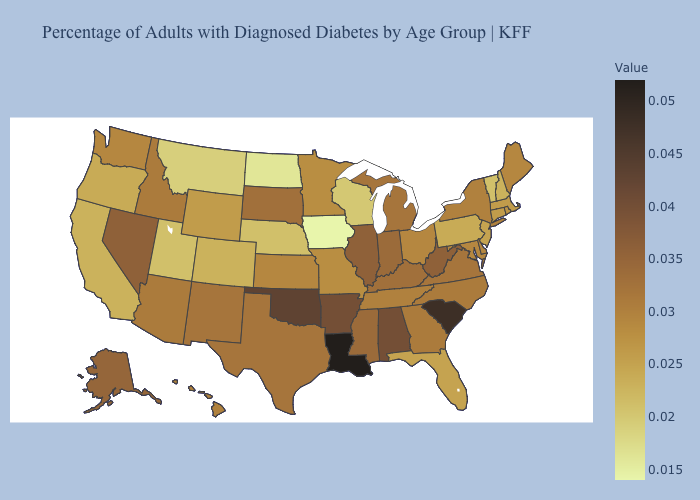Which states hav the highest value in the Northeast?
Be succinct. New York. Among the states that border North Dakota , which have the lowest value?
Short answer required. Montana. Does the map have missing data?
Short answer required. No. Which states have the lowest value in the Northeast?
Keep it brief. Vermont. Which states have the highest value in the USA?
Write a very short answer. Louisiana. Among the states that border Oregon , which have the highest value?
Quick response, please. Nevada. Does West Virginia have a higher value than California?
Be succinct. Yes. Among the states that border Mississippi , does Louisiana have the lowest value?
Quick response, please. No. 